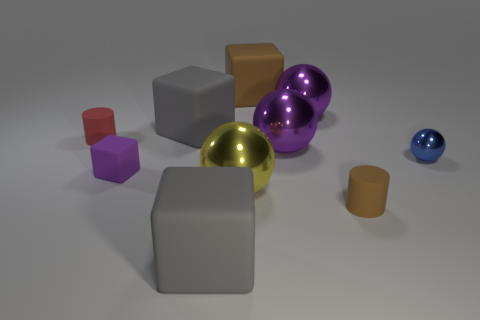Subtract all brown matte blocks. How many blocks are left? 3 Subtract all cubes. How many objects are left? 6 Subtract 1 spheres. How many spheres are left? 3 Subtract all blue cubes. Subtract all brown cylinders. How many cubes are left? 4 Subtract all brown cubes. How many gray cylinders are left? 0 Subtract all tiny brown cylinders. Subtract all big yellow metallic objects. How many objects are left? 8 Add 4 purple things. How many purple things are left? 7 Add 9 tiny brown cylinders. How many tiny brown cylinders exist? 10 Subtract all brown cylinders. How many cylinders are left? 1 Subtract 0 green blocks. How many objects are left? 10 